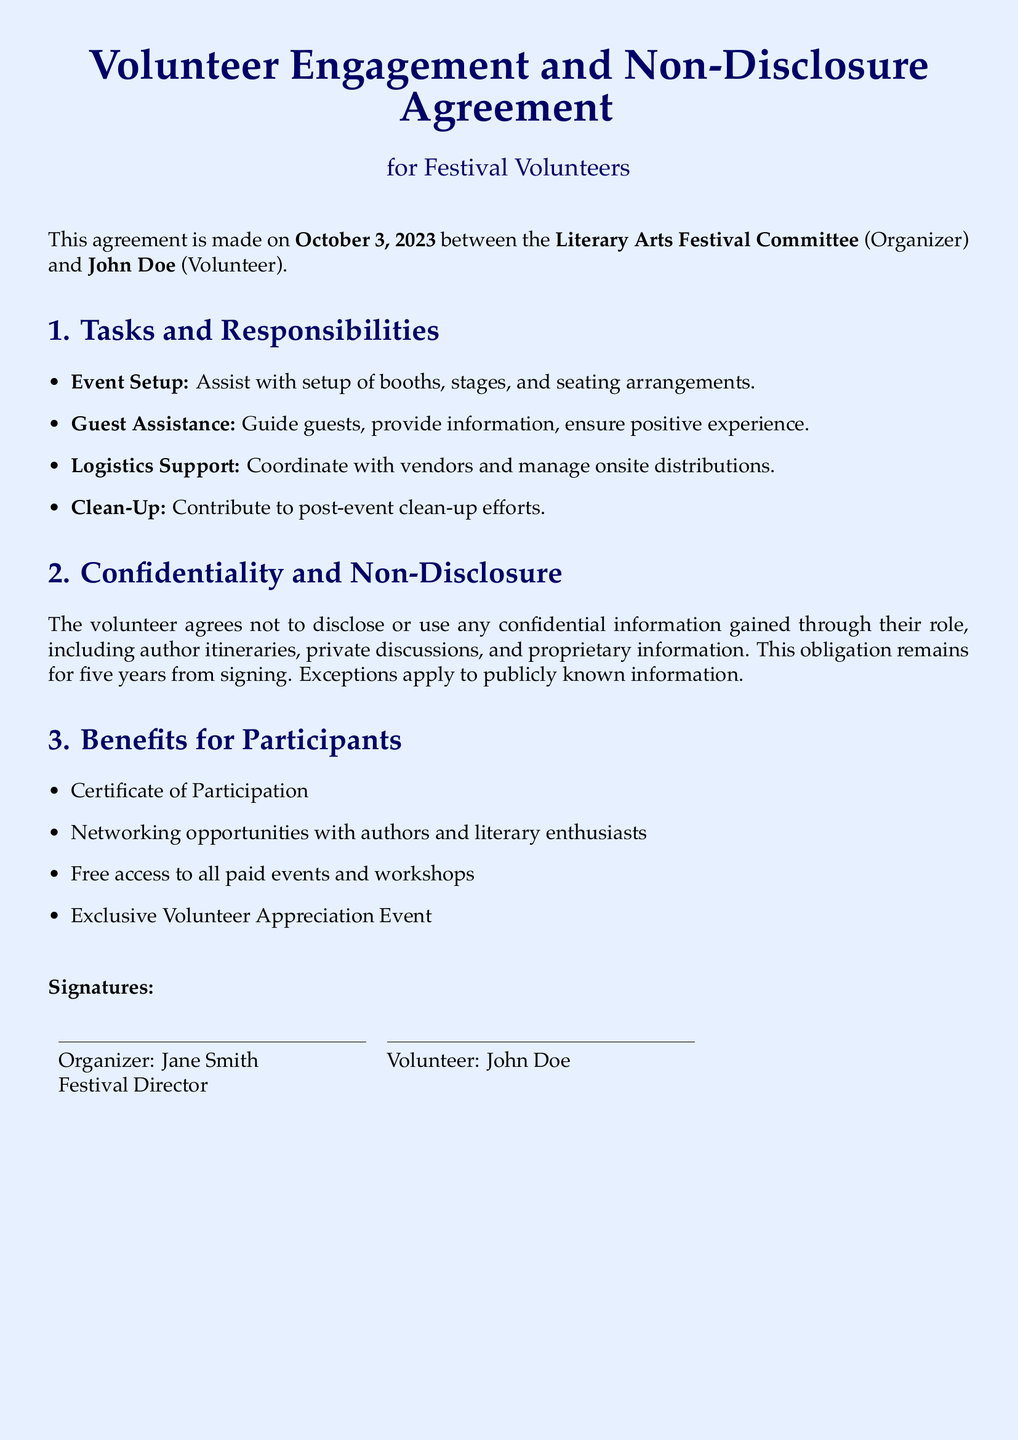What is the date of the agreement? The date of the agreement is stated at the beginning of the document.
Answer: October 3, 2023 Who are the parties involved in the agreement? The document lists the parties involved at the beginning.
Answer: Literary Arts Festival Committee and John Doe What is one of the tasks volunteers are responsible for? The document outlines specific tasks assigned to volunteers.
Answer: Event Setup How long does the confidentiality obligation last? The document specifies the duration of the confidentiality clause.
Answer: Five years What is one benefit volunteers receive? The document lists benefits available to volunteers.
Answer: Certificate of Participation Who is the organizer? The document identifies the organizer in the introductory section.
Answer: Jane Smith What type of event do volunteers get free access to? The list of benefits includes access to specific events.
Answer: Paid events and workshops What role does John Doe have in this agreement? John Doe's role in the agreement is defined by his participation status.
Answer: Volunteer 